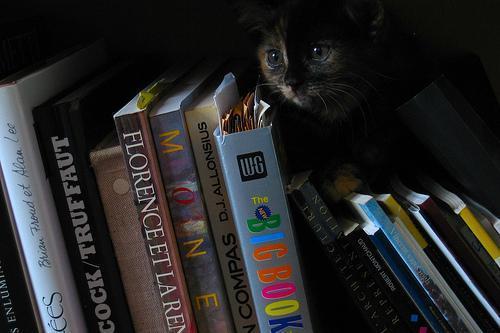How many books are in the photo?
Give a very brief answer. 9. 